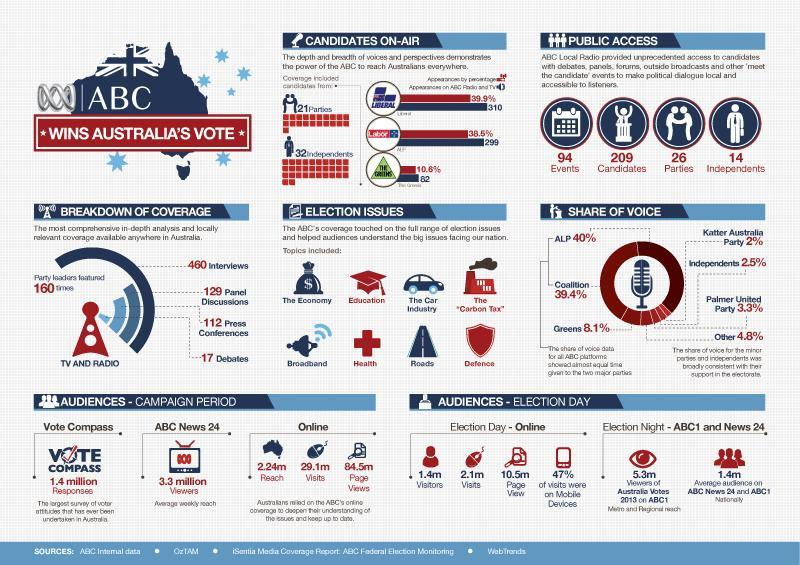How many million views were there for ABC News 24?
Answer the question with a short phrase. 3.3 million viewers How many responses were recorded in vote compass? 1.4 million responses Which was the second last topic of the election issues? Roads How many visits were there on Election Day- Online? 2.1m visits How many election issues were reported by ABC? 8 How many independents were present in the ABC local radio public access? 14 independents What was the page view for Election Day Online? 10.5m To how many candidates ABC Local radio provided unprecedented access? 209 candidates How many events were conducted by ABC Local radio? 94 How many parties were present in the ABC local radio public access? 26 parties 